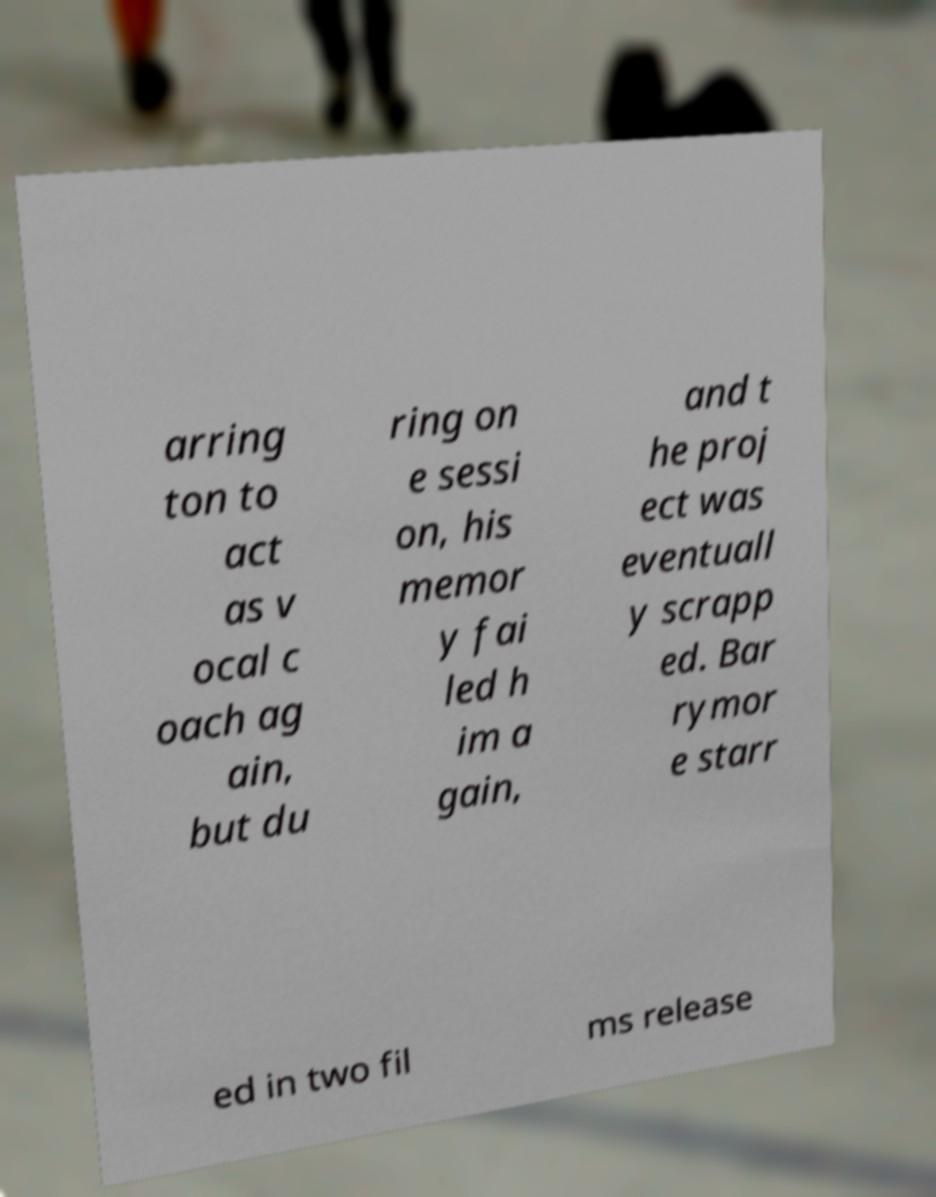Can you accurately transcribe the text from the provided image for me? arring ton to act as v ocal c oach ag ain, but du ring on e sessi on, his memor y fai led h im a gain, and t he proj ect was eventuall y scrapp ed. Bar rymor e starr ed in two fil ms release 